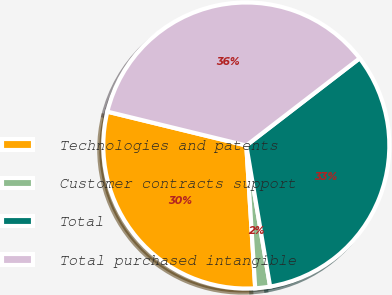Convert chart to OTSL. <chart><loc_0><loc_0><loc_500><loc_500><pie_chart><fcel>Technologies and patents<fcel>Customer contracts support<fcel>Total<fcel>Total purchased intangible<nl><fcel>29.8%<fcel>1.67%<fcel>32.78%<fcel>35.76%<nl></chart> 